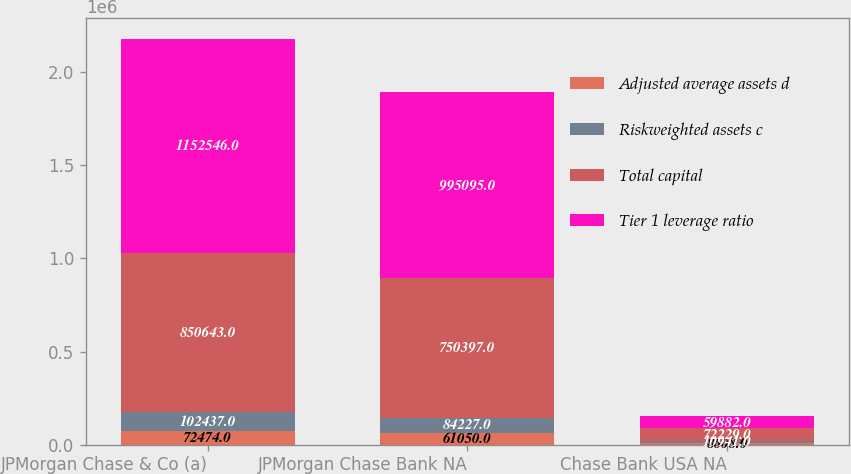<chart> <loc_0><loc_0><loc_500><loc_500><stacked_bar_chart><ecel><fcel>JPMorgan Chase & Co (a)<fcel>JPMorgan Chase Bank NA<fcel>Chase Bank USA NA<nl><fcel>Adjusted average assets d<fcel>72474<fcel>61050<fcel>8608<nl><fcel>Riskweighted assets c<fcel>102437<fcel>84227<fcel>10941<nl><fcel>Total capital<fcel>850643<fcel>750397<fcel>72229<nl><fcel>Tier 1 leverage ratio<fcel>1.15255e+06<fcel>995095<fcel>59882<nl></chart> 